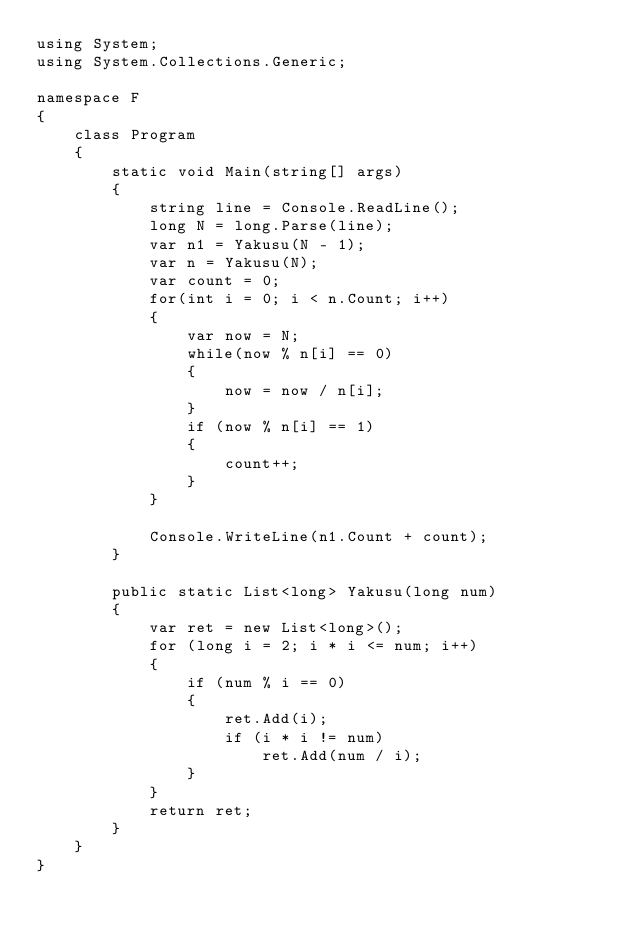<code> <loc_0><loc_0><loc_500><loc_500><_C#_>using System;
using System.Collections.Generic;

namespace F
{
    class Program
    {
        static void Main(string[] args)
        {
            string line = Console.ReadLine();
            long N = long.Parse(line);
            var n1 = Yakusu(N - 1);
            var n = Yakusu(N);
            var count = 0;
            for(int i = 0; i < n.Count; i++)
            {
                var now = N;
                while(now % n[i] == 0)
                {
                    now = now / n[i];
                }
                if (now % n[i] == 1)
                {
                    count++;
                }
            }

            Console.WriteLine(n1.Count + count);
        }

        public static List<long> Yakusu(long num)
        {
            var ret = new List<long>();
            for (long i = 2; i * i <= num; i++)
            {
                if (num % i == 0)
                {
                    ret.Add(i);
                    if (i * i != num)
                        ret.Add(num / i);
                }
            }
            return ret;
        }
    }
}
</code> 